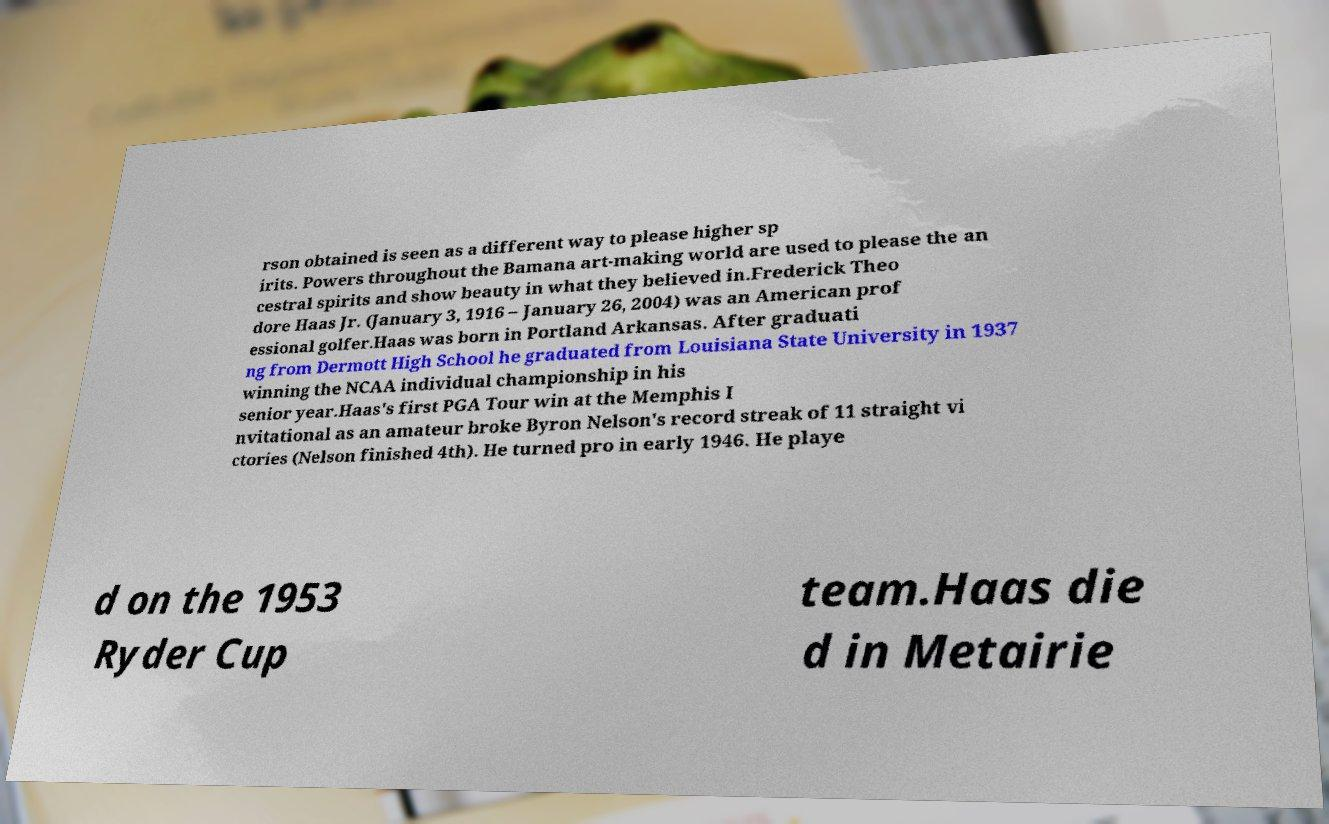Could you assist in decoding the text presented in this image and type it out clearly? rson obtained is seen as a different way to please higher sp irits. Powers throughout the Bamana art-making world are used to please the an cestral spirits and show beauty in what they believed in.Frederick Theo dore Haas Jr. (January 3, 1916 – January 26, 2004) was an American prof essional golfer.Haas was born in Portland Arkansas. After graduati ng from Dermott High School he graduated from Louisiana State University in 1937 winning the NCAA individual championship in his senior year.Haas's first PGA Tour win at the Memphis I nvitational as an amateur broke Byron Nelson's record streak of 11 straight vi ctories (Nelson finished 4th). He turned pro in early 1946. He playe d on the 1953 Ryder Cup team.Haas die d in Metairie 